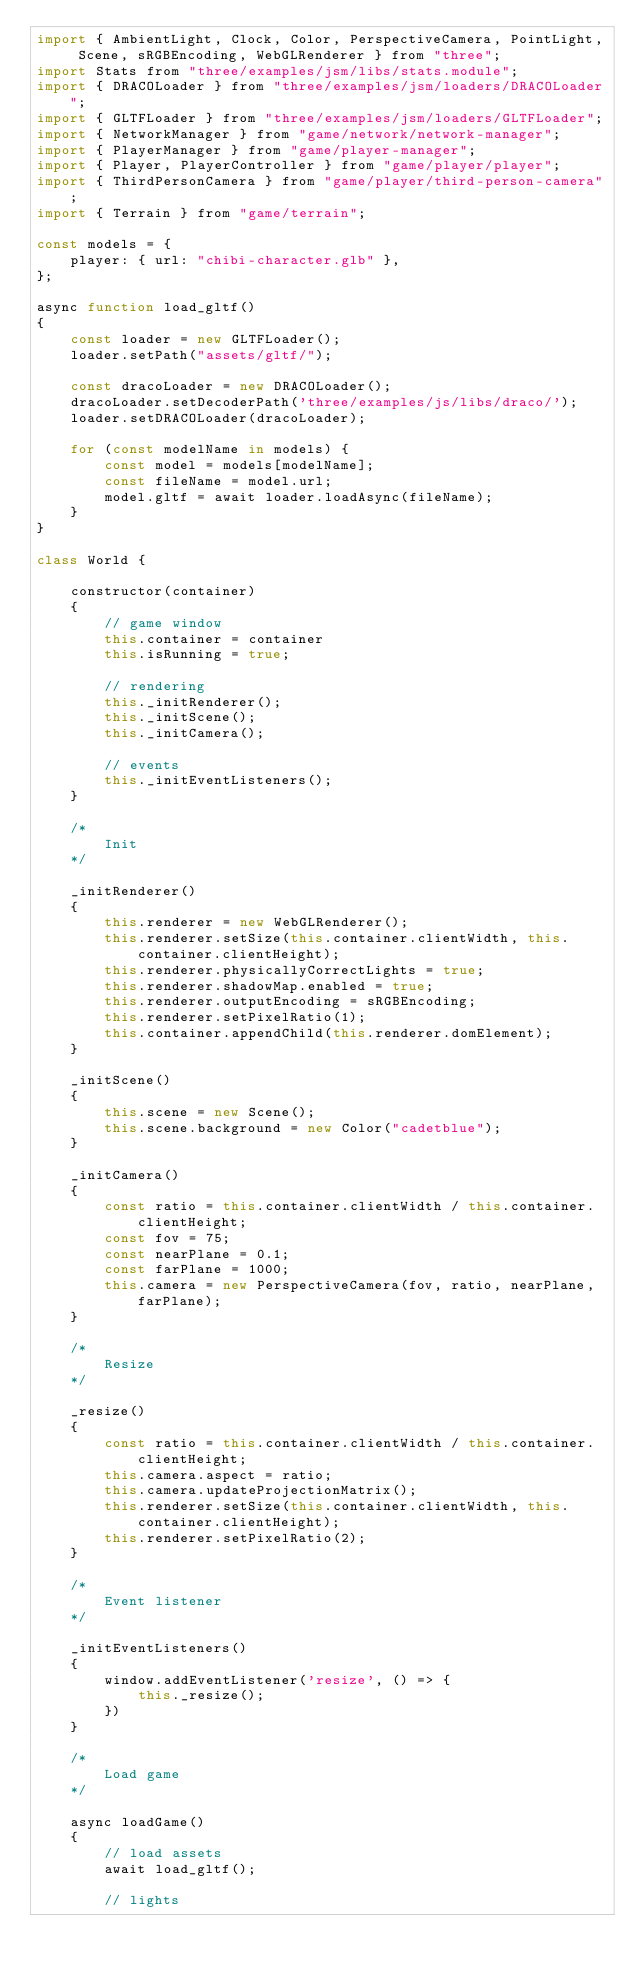Convert code to text. <code><loc_0><loc_0><loc_500><loc_500><_JavaScript_>import { AmbientLight, Clock, Color, PerspectiveCamera, PointLight, Scene, sRGBEncoding, WebGLRenderer } from "three";
import Stats from "three/examples/jsm/libs/stats.module";
import { DRACOLoader } from "three/examples/jsm/loaders/DRACOLoader";
import { GLTFLoader } from "three/examples/jsm/loaders/GLTFLoader";
import { NetworkManager } from "game/network/network-manager";
import { PlayerManager } from "game/player-manager";
import { Player, PlayerController } from "game/player/player";
import { ThirdPersonCamera } from "game/player/third-person-camera";
import { Terrain } from "game/terrain";

const models = {
    player: { url: "chibi-character.glb" },
};

async function load_gltf()
{
    const loader = new GLTFLoader();
    loader.setPath("assets/gltf/");

    const dracoLoader = new DRACOLoader();
    dracoLoader.setDecoderPath('three/examples/js/libs/draco/');
    loader.setDRACOLoader(dracoLoader);

    for (const modelName in models) {
        const model = models[modelName];
        const fileName = model.url;
        model.gltf = await loader.loadAsync(fileName);
    }
}

class World {

    constructor(container)
    {
        // game window
        this.container = container
        this.isRunning = true;

        // rendering
        this._initRenderer();
        this._initScene();
        this._initCamera();

        // events
        this._initEventListeners();
    }

    /*
        Init
    */

    _initRenderer()
    {
        this.renderer = new WebGLRenderer();
        this.renderer.setSize(this.container.clientWidth, this.container.clientHeight);
        this.renderer.physicallyCorrectLights = true;
        this.renderer.shadowMap.enabled = true;
        this.renderer.outputEncoding = sRGBEncoding;
        this.renderer.setPixelRatio(1);
        this.container.appendChild(this.renderer.domElement);
    }

    _initScene()
    {
        this.scene = new Scene();
        this.scene.background = new Color("cadetblue");
    }

    _initCamera()
    {
        const ratio = this.container.clientWidth / this.container.clientHeight;
        const fov = 75;
        const nearPlane = 0.1;
        const farPlane = 1000;
        this.camera = new PerspectiveCamera(fov, ratio, nearPlane, farPlane);
    }

    /*
        Resize
    */

    _resize()
    {
        const ratio = this.container.clientWidth / this.container.clientHeight;
        this.camera.aspect = ratio;
        this.camera.updateProjectionMatrix();
        this.renderer.setSize(this.container.clientWidth, this.container.clientHeight);
        this.renderer.setPixelRatio(2);
    }

    /*
        Event listener
    */

    _initEventListeners()
    {
        window.addEventListener('resize', () => {
            this._resize();
        })
    }

    /*
        Load game
    */

    async loadGame()
    {
        // load assets
        await load_gltf();

        // lights</code> 